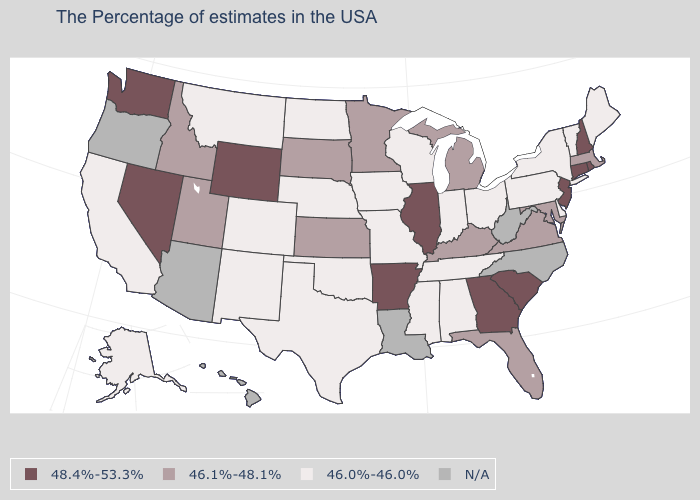What is the value of Delaware?
Concise answer only. 46.0%-46.0%. Which states have the highest value in the USA?
Quick response, please. Rhode Island, New Hampshire, Connecticut, New Jersey, South Carolina, Georgia, Illinois, Arkansas, Wyoming, Nevada, Washington. What is the value of Maine?
Be succinct. 46.0%-46.0%. What is the value of Arkansas?
Be succinct. 48.4%-53.3%. Does the map have missing data?
Be succinct. Yes. What is the highest value in the West ?
Answer briefly. 48.4%-53.3%. Name the states that have a value in the range 46.1%-48.1%?
Concise answer only. Massachusetts, Maryland, Virginia, Florida, Michigan, Kentucky, Minnesota, Kansas, South Dakota, Utah, Idaho. Name the states that have a value in the range 46.0%-46.0%?
Answer briefly. Maine, Vermont, New York, Delaware, Pennsylvania, Ohio, Indiana, Alabama, Tennessee, Wisconsin, Mississippi, Missouri, Iowa, Nebraska, Oklahoma, Texas, North Dakota, Colorado, New Mexico, Montana, California, Alaska. Does the first symbol in the legend represent the smallest category?
Be succinct. No. What is the value of West Virginia?
Keep it brief. N/A. How many symbols are there in the legend?
Be succinct. 4. Which states have the lowest value in the USA?
Write a very short answer. Maine, Vermont, New York, Delaware, Pennsylvania, Ohio, Indiana, Alabama, Tennessee, Wisconsin, Mississippi, Missouri, Iowa, Nebraska, Oklahoma, Texas, North Dakota, Colorado, New Mexico, Montana, California, Alaska. What is the value of Georgia?
Write a very short answer. 48.4%-53.3%. 